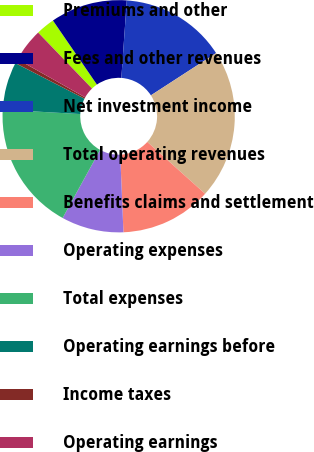Convert chart. <chart><loc_0><loc_0><loc_500><loc_500><pie_chart><fcel>Premiums and other<fcel>Fees and other revenues<fcel>Net investment income<fcel>Total operating revenues<fcel>Benefits claims and settlement<fcel>Operating expenses<fcel>Total expenses<fcel>Operating earnings before<fcel>Income taxes<fcel>Operating earnings<nl><fcel>2.62%<fcel>10.69%<fcel>14.73%<fcel>20.79%<fcel>12.71%<fcel>8.67%<fcel>17.89%<fcel>6.66%<fcel>0.6%<fcel>4.64%<nl></chart> 